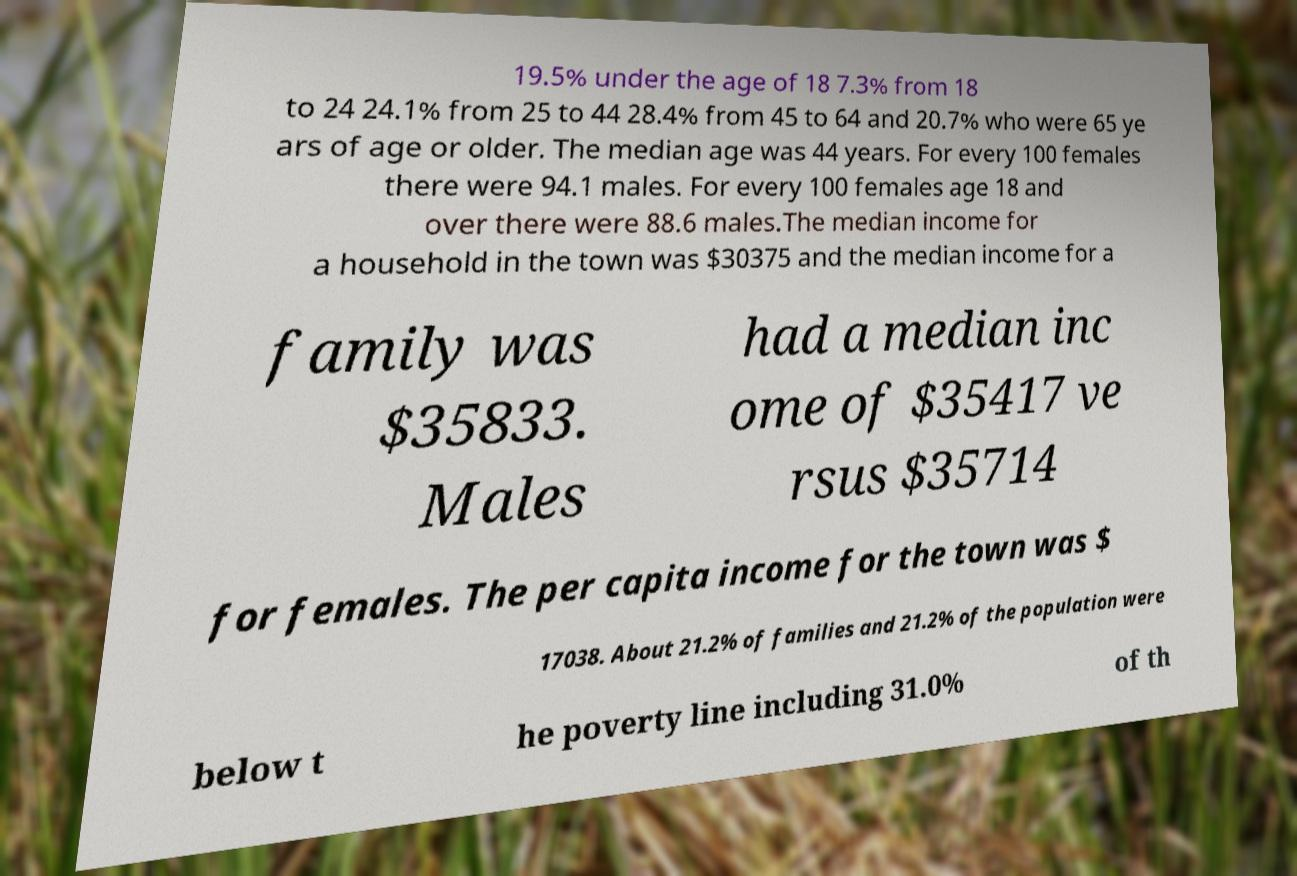I need the written content from this picture converted into text. Can you do that? 19.5% under the age of 18 7.3% from 18 to 24 24.1% from 25 to 44 28.4% from 45 to 64 and 20.7% who were 65 ye ars of age or older. The median age was 44 years. For every 100 females there were 94.1 males. For every 100 females age 18 and over there were 88.6 males.The median income for a household in the town was $30375 and the median income for a family was $35833. Males had a median inc ome of $35417 ve rsus $35714 for females. The per capita income for the town was $ 17038. About 21.2% of families and 21.2% of the population were below t he poverty line including 31.0% of th 